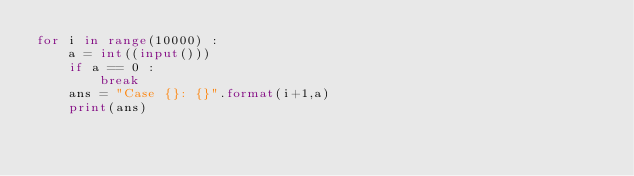Convert code to text. <code><loc_0><loc_0><loc_500><loc_500><_Python_>for i in range(10000) :
    a = int((input()))
    if a == 0 :
        break
    ans = "Case {}: {}".format(i+1,a)
    print(ans)
</code> 